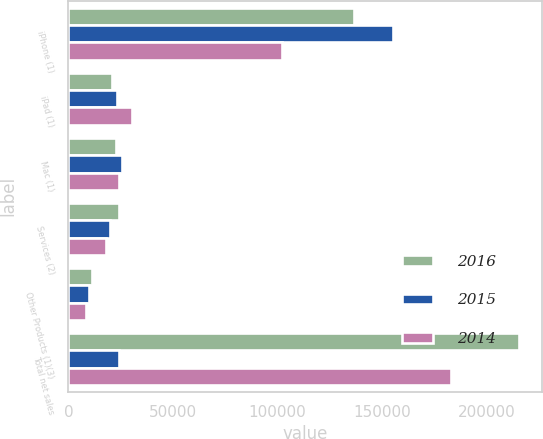Convert chart to OTSL. <chart><loc_0><loc_0><loc_500><loc_500><stacked_bar_chart><ecel><fcel>iPhone (1)<fcel>iPad (1)<fcel>Mac (1)<fcel>Services (2)<fcel>Other Products (1)(3)<fcel>Total net sales<nl><fcel>2016<fcel>136700<fcel>20628<fcel>22831<fcel>24348<fcel>11132<fcel>215639<nl><fcel>2015<fcel>155041<fcel>23227<fcel>25471<fcel>19909<fcel>10067<fcel>24079<nl><fcel>2014<fcel>101991<fcel>30283<fcel>24079<fcel>18063<fcel>8379<fcel>182795<nl></chart> 